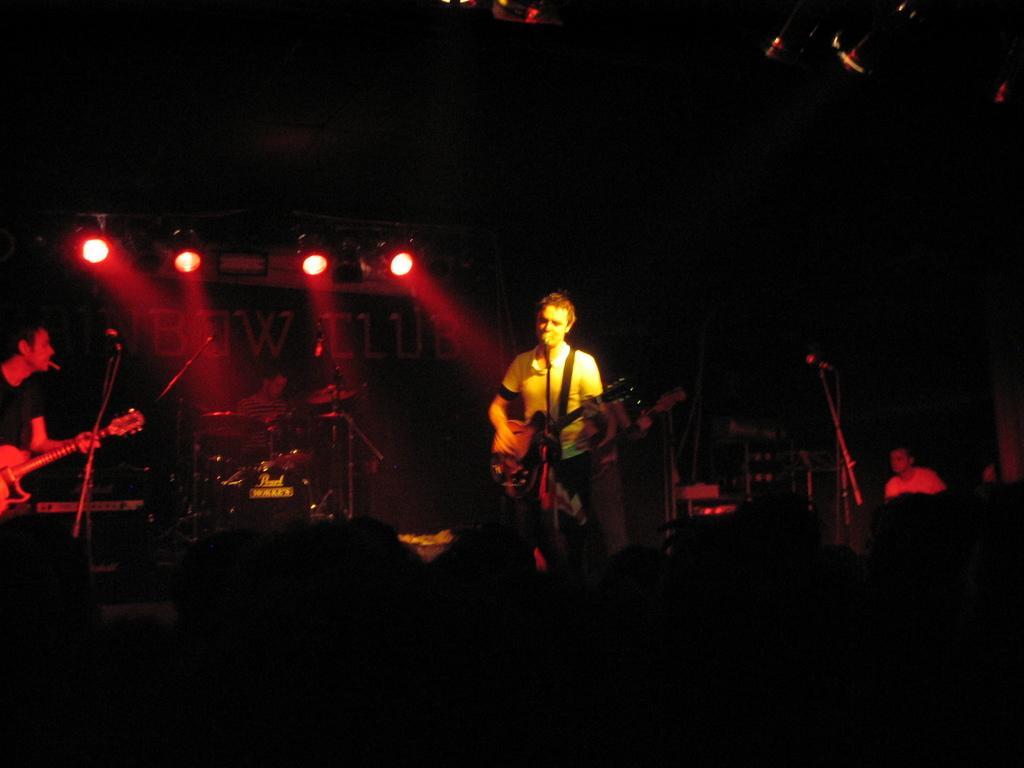In one or two sentences, can you explain what this image depicts? In this image I can see few people are standing and holding guitars. I can also see few mics over here. In the background I can see a person is sitting next to a drum set. 